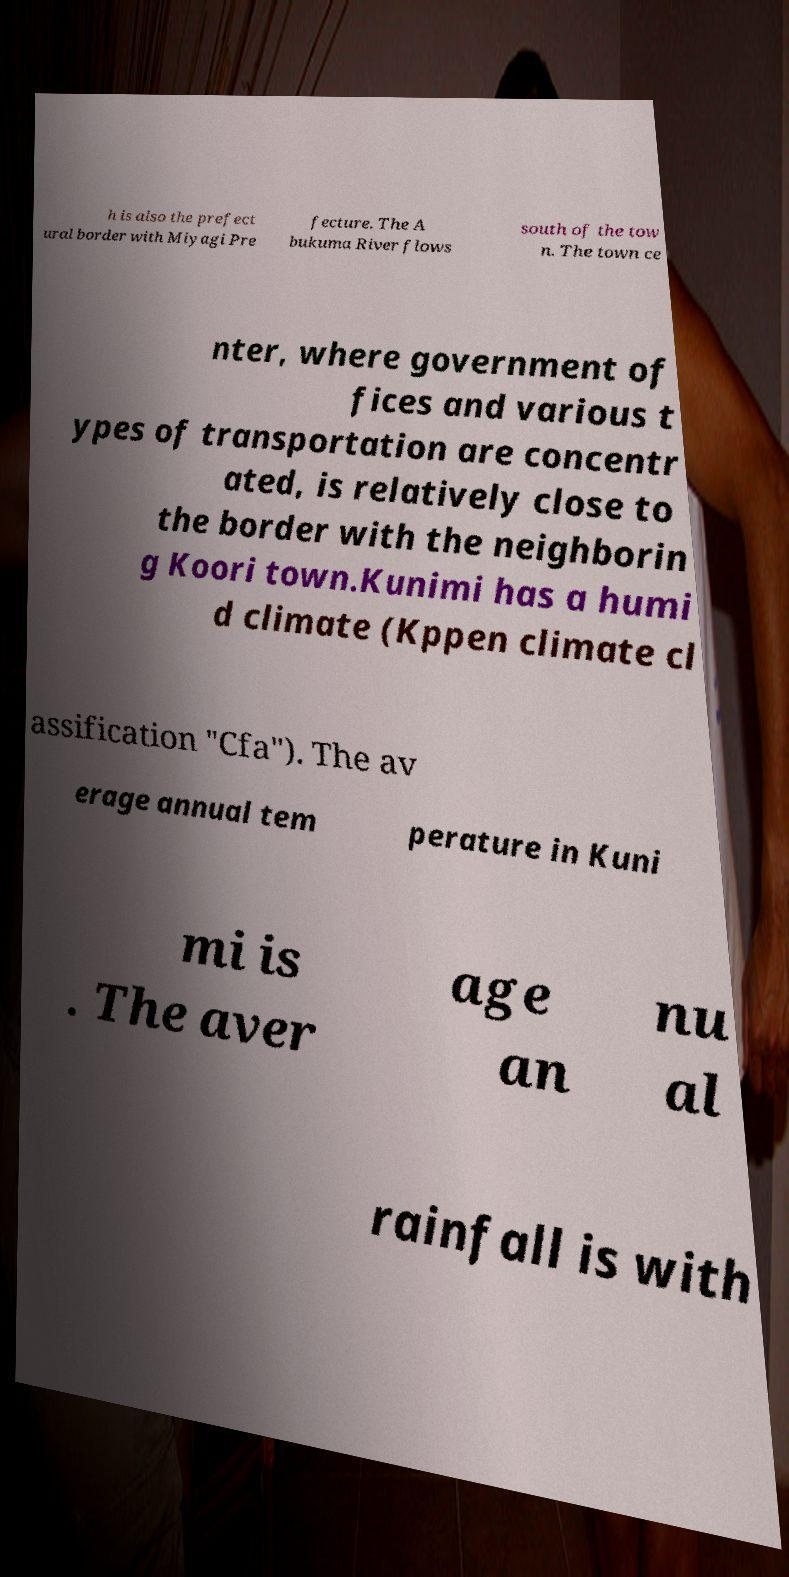Can you accurately transcribe the text from the provided image for me? h is also the prefect ural border with Miyagi Pre fecture. The A bukuma River flows south of the tow n. The town ce nter, where government of fices and various t ypes of transportation are concentr ated, is relatively close to the border with the neighborin g Koori town.Kunimi has a humi d climate (Kppen climate cl assification "Cfa"). The av erage annual tem perature in Kuni mi is . The aver age an nu al rainfall is with 